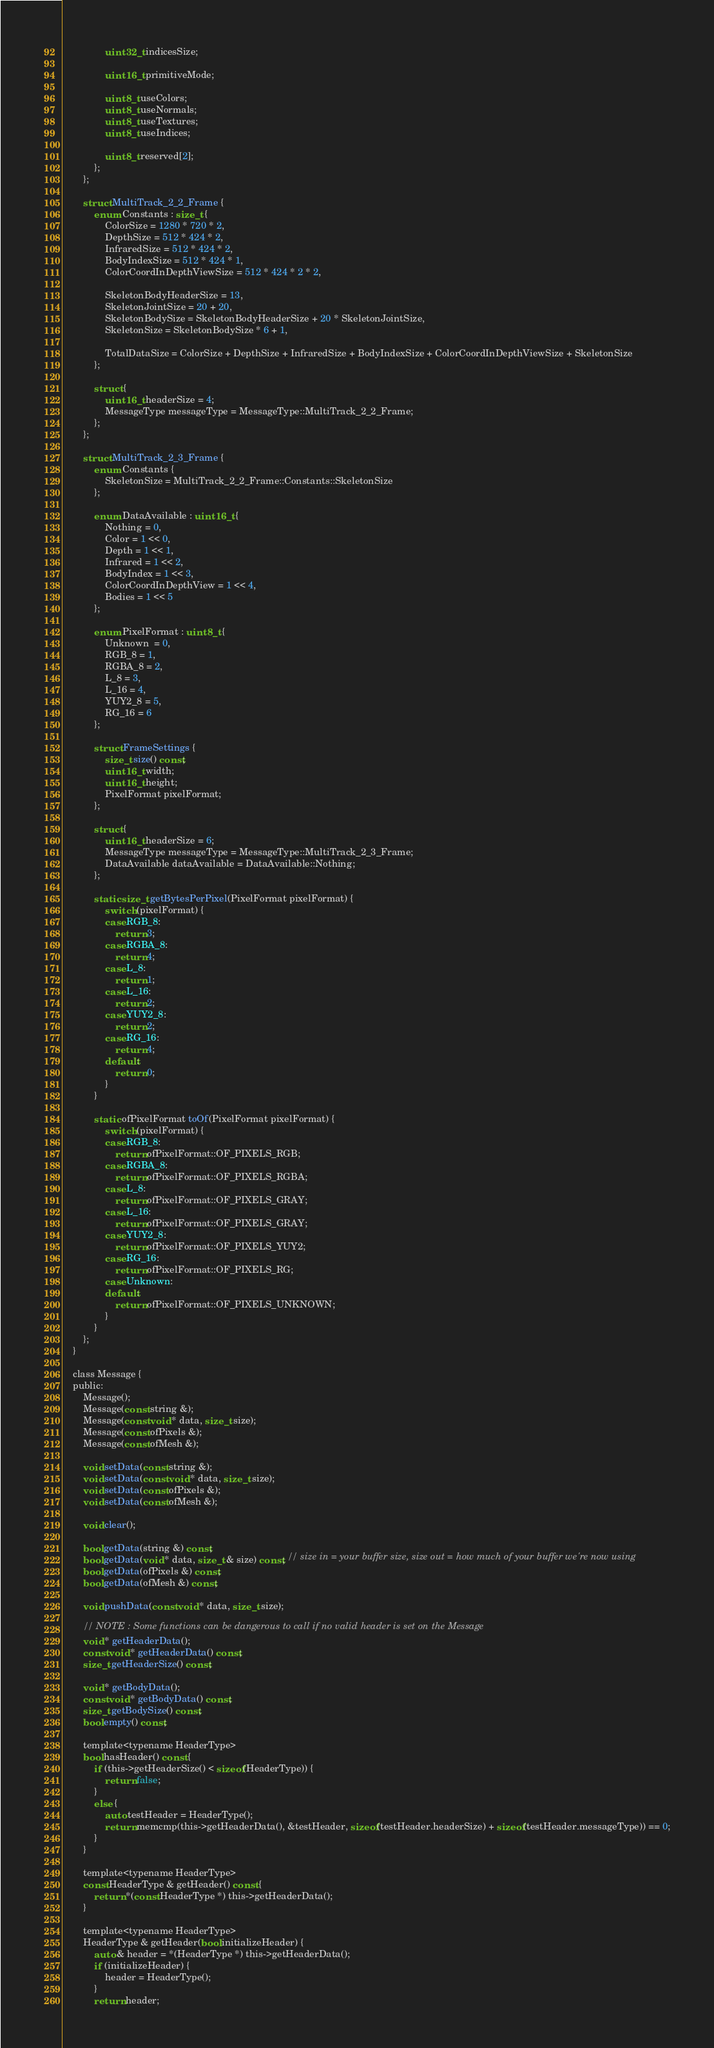<code> <loc_0><loc_0><loc_500><loc_500><_C_>				uint32_t indicesSize;

				uint16_t primitiveMode;

				uint8_t useColors;
				uint8_t useNormals;
				uint8_t useTextures;
				uint8_t useIndices;

				uint8_t reserved[2];
			};
		};

		struct MultiTrack_2_2_Frame {
			enum Constants : size_t {
				ColorSize = 1280 * 720 * 2,
				DepthSize = 512 * 424 * 2,
				InfraredSize = 512 * 424 * 2,
				BodyIndexSize = 512 * 424 * 1,
				ColorCoordInDepthViewSize = 512 * 424 * 2 * 2,

				SkeletonBodyHeaderSize = 13,
				SkeletonJointSize = 20 + 20,
				SkeletonBodySize = SkeletonBodyHeaderSize + 20 * SkeletonJointSize,
				SkeletonSize = SkeletonBodySize * 6 + 1,

				TotalDataSize = ColorSize + DepthSize + InfraredSize + BodyIndexSize + ColorCoordInDepthViewSize + SkeletonSize
			};

			struct {
				uint16_t headerSize = 4;
				MessageType messageType = MessageType::MultiTrack_2_2_Frame;
			};
		};

		struct MultiTrack_2_3_Frame {
			enum Constants {
				SkeletonSize = MultiTrack_2_2_Frame::Constants::SkeletonSize
			};

			enum DataAvailable : uint16_t {
				Nothing = 0,
				Color = 1 << 0,
				Depth = 1 << 1,
				Infrared = 1 << 2,
				BodyIndex = 1 << 3,
				ColorCoordInDepthView = 1 << 4,
				Bodies = 1 << 5
			};

			enum PixelFormat : uint8_t {
				Unknown  = 0,
				RGB_8 = 1,
				RGBA_8 = 2,
				L_8 = 3,
				L_16 = 4,
				YUY2_8 = 5,
				RG_16 = 6
			};

			struct FrameSettings {
				size_t size() const;
				uint16_t width;
				uint16_t height;
				PixelFormat pixelFormat;
			};

			struct {
				uint16_t headerSize = 6;
				MessageType messageType = MessageType::MultiTrack_2_3_Frame;
				DataAvailable dataAvailable = DataAvailable::Nothing;
			};

			static size_t getBytesPerPixel(PixelFormat pixelFormat) {
				switch (pixelFormat) {
				case RGB_8:
					return 3;
				case RGBA_8:
					return 4;
				case L_8:
					return 1;
				case L_16:
					return 2;
				case YUY2_8:
					return 2;
				case RG_16:
					return 4;
				default:
					return 0;
				}
			}

			static ofPixelFormat toOf(PixelFormat pixelFormat) {
				switch (pixelFormat) {
				case RGB_8:
					return ofPixelFormat::OF_PIXELS_RGB;
				case RGBA_8:
					return ofPixelFormat::OF_PIXELS_RGBA;
				case L_8:
					return ofPixelFormat::OF_PIXELS_GRAY;
				case L_16:
					return ofPixelFormat::OF_PIXELS_GRAY;
				case YUY2_8:
					return ofPixelFormat::OF_PIXELS_YUY2;
				case RG_16:
					return ofPixelFormat::OF_PIXELS_RG;
				case Unknown:
				default:
					return ofPixelFormat::OF_PIXELS_UNKNOWN;
				}
			}
		};
	}

	class Message {
	public:
		Message();
		Message(const string &);
		Message(const void * data, size_t size);
		Message(const ofPixels &);
		Message(const ofMesh &);
		
		void setData(const string &);
		void setData(const void * data, size_t size);
		void setData(const ofPixels &);
		void setData(const ofMesh &);

		void clear();

		bool getData(string &) const;
		bool getData(void * data, size_t & size) const; // size in = your buffer size, size out = how much of your buffer we're now using
		bool getData(ofPixels &) const;
		bool getData(ofMesh &) const;

		void pushData(const void * data, size_t size);

		// NOTE : Some functions can be dangerous to call if no valid header is set on the Message
		void * getHeaderData();
		const void * getHeaderData() const;
		size_t getHeaderSize() const;

		void * getBodyData();
		const void * getBodyData() const;
		size_t getBodySize() const;
		bool empty() const;

		template<typename HeaderType>
		bool hasHeader() const {
			if (this->getHeaderSize() < sizeof(HeaderType)) {
				return false;
			}
			else {
				auto testHeader = HeaderType();
				return memcmp(this->getHeaderData(), &testHeader, sizeof(testHeader.headerSize) + sizeof(testHeader.messageType)) == 0;
			}
		}

		template<typename HeaderType>
		const HeaderType & getHeader() const {
			return *(const HeaderType *) this->getHeaderData();
		}

		template<typename HeaderType>
		HeaderType & getHeader(bool initializeHeader) {
			auto & header = *(HeaderType *) this->getHeaderData();
			if (initializeHeader) {
				header = HeaderType();
			}
			return header;</code> 